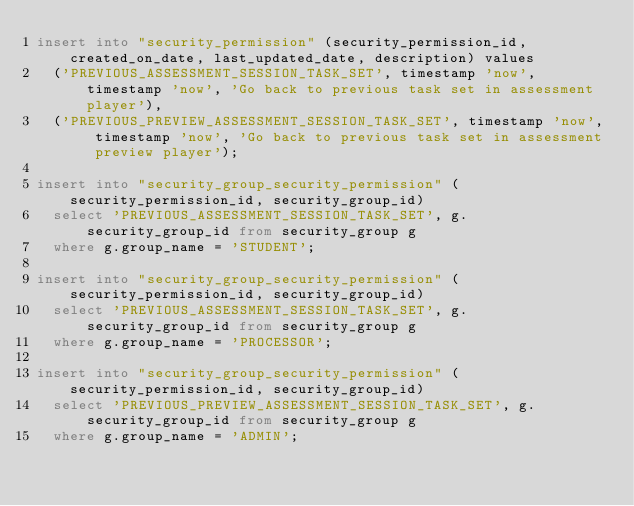Convert code to text. <code><loc_0><loc_0><loc_500><loc_500><_SQL_>insert into "security_permission" (security_permission_id, created_on_date, last_updated_date, description) values
  ('PREVIOUS_ASSESSMENT_SESSION_TASK_SET', timestamp 'now', timestamp 'now', 'Go back to previous task set in assessment player'),
  ('PREVIOUS_PREVIEW_ASSESSMENT_SESSION_TASK_SET', timestamp 'now', timestamp 'now', 'Go back to previous task set in assessment preview player');

insert into "security_group_security_permission" (security_permission_id, security_group_id)
  select 'PREVIOUS_ASSESSMENT_SESSION_TASK_SET', g.security_group_id from security_group g
  where g.group_name = 'STUDENT';

insert into "security_group_security_permission" (security_permission_id, security_group_id)
  select 'PREVIOUS_ASSESSMENT_SESSION_TASK_SET', g.security_group_id from security_group g
  where g.group_name = 'PROCESSOR';

insert into "security_group_security_permission" (security_permission_id, security_group_id)
  select 'PREVIOUS_PREVIEW_ASSESSMENT_SESSION_TASK_SET', g.security_group_id from security_group g
  where g.group_name = 'ADMIN';


</code> 